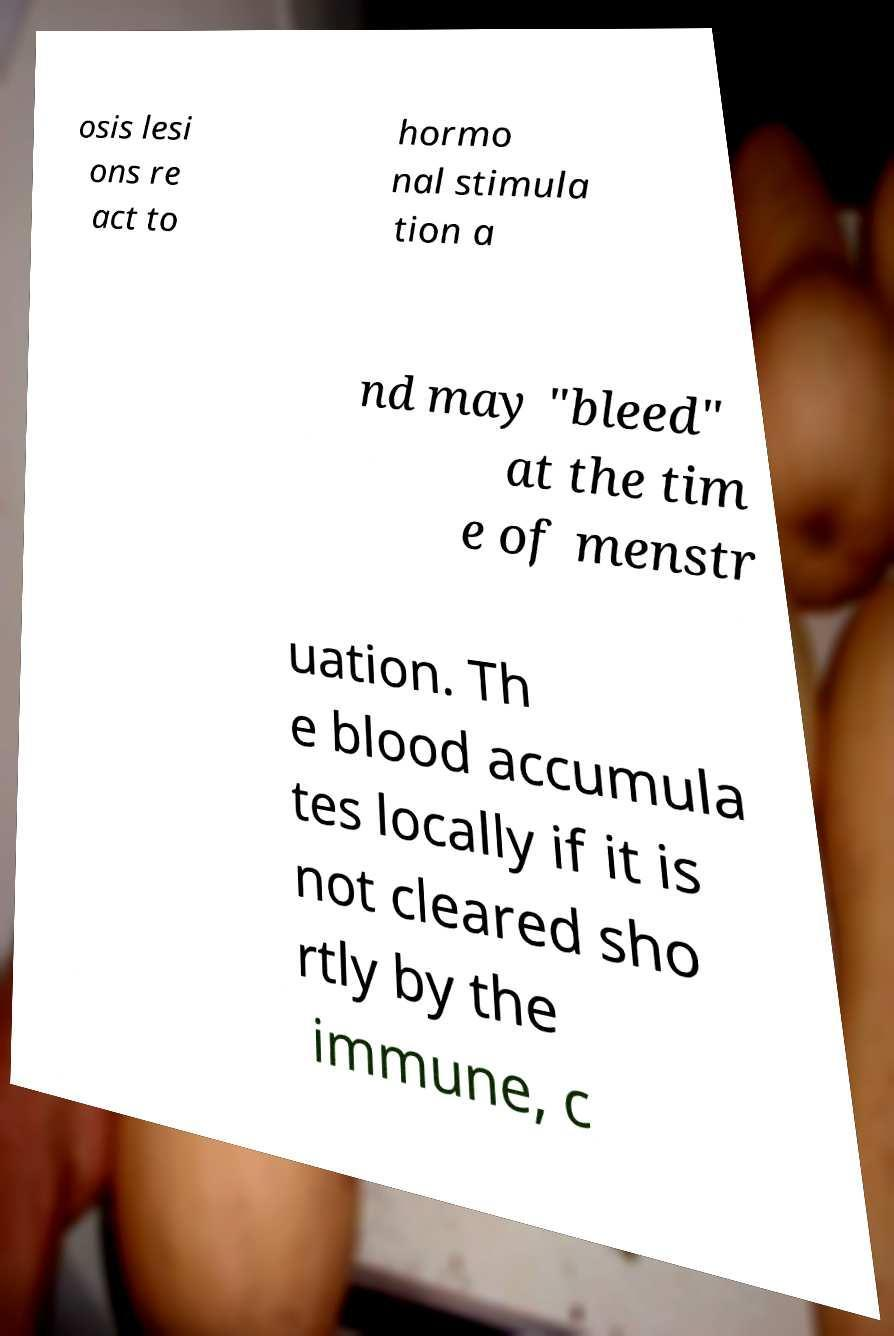Can you read and provide the text displayed in the image?This photo seems to have some interesting text. Can you extract and type it out for me? osis lesi ons re act to hormo nal stimula tion a nd may "bleed" at the tim e of menstr uation. Th e blood accumula tes locally if it is not cleared sho rtly by the immune, c 